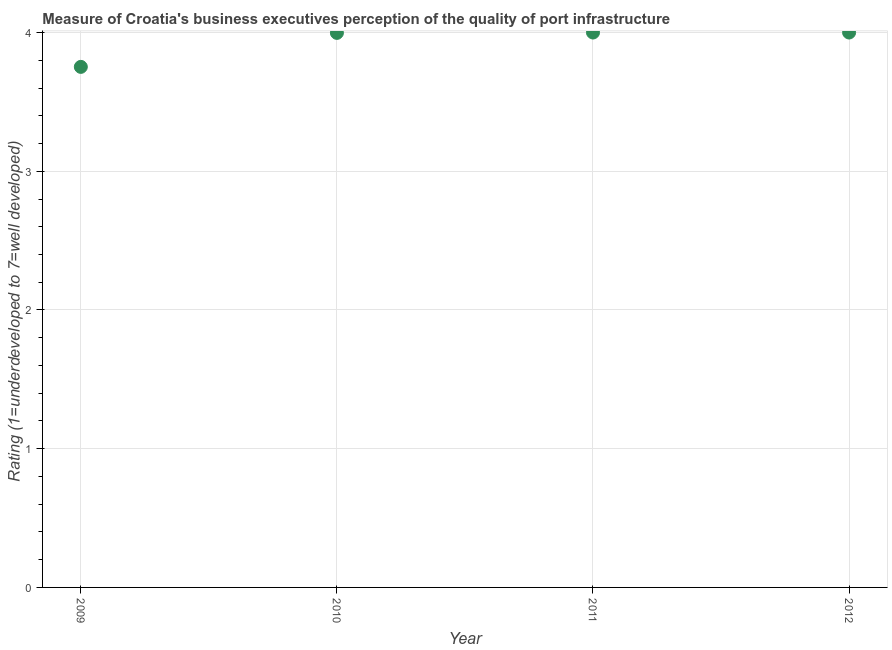What is the rating measuring quality of port infrastructure in 2011?
Provide a short and direct response. 4. Across all years, what is the maximum rating measuring quality of port infrastructure?
Provide a succinct answer. 4. Across all years, what is the minimum rating measuring quality of port infrastructure?
Make the answer very short. 3.75. What is the sum of the rating measuring quality of port infrastructure?
Offer a very short reply. 15.75. What is the average rating measuring quality of port infrastructure per year?
Keep it short and to the point. 3.94. What is the median rating measuring quality of port infrastructure?
Offer a terse response. 4. In how many years, is the rating measuring quality of port infrastructure greater than 3.6 ?
Make the answer very short. 4. Do a majority of the years between 2011 and 2010 (inclusive) have rating measuring quality of port infrastructure greater than 1.4 ?
Ensure brevity in your answer.  No. What is the ratio of the rating measuring quality of port infrastructure in 2010 to that in 2011?
Offer a terse response. 1. Is the difference between the rating measuring quality of port infrastructure in 2010 and 2012 greater than the difference between any two years?
Provide a short and direct response. No. What is the difference between the highest and the second highest rating measuring quality of port infrastructure?
Offer a terse response. 0. Is the sum of the rating measuring quality of port infrastructure in 2010 and 2012 greater than the maximum rating measuring quality of port infrastructure across all years?
Provide a short and direct response. Yes. What is the difference between the highest and the lowest rating measuring quality of port infrastructure?
Your answer should be compact. 0.25. Does the graph contain any zero values?
Offer a very short reply. No. What is the title of the graph?
Ensure brevity in your answer.  Measure of Croatia's business executives perception of the quality of port infrastructure. What is the label or title of the X-axis?
Provide a short and direct response. Year. What is the label or title of the Y-axis?
Offer a very short reply. Rating (1=underdeveloped to 7=well developed) . What is the Rating (1=underdeveloped to 7=well developed)  in 2009?
Your answer should be compact. 3.75. What is the Rating (1=underdeveloped to 7=well developed)  in 2010?
Offer a terse response. 4. What is the Rating (1=underdeveloped to 7=well developed)  in 2011?
Provide a succinct answer. 4. What is the Rating (1=underdeveloped to 7=well developed)  in 2012?
Your answer should be very brief. 4. What is the difference between the Rating (1=underdeveloped to 7=well developed)  in 2009 and 2010?
Give a very brief answer. -0.24. What is the difference between the Rating (1=underdeveloped to 7=well developed)  in 2009 and 2011?
Provide a succinct answer. -0.25. What is the difference between the Rating (1=underdeveloped to 7=well developed)  in 2009 and 2012?
Your answer should be very brief. -0.25. What is the difference between the Rating (1=underdeveloped to 7=well developed)  in 2010 and 2011?
Your answer should be compact. -0. What is the difference between the Rating (1=underdeveloped to 7=well developed)  in 2010 and 2012?
Offer a very short reply. -0. What is the difference between the Rating (1=underdeveloped to 7=well developed)  in 2011 and 2012?
Give a very brief answer. 0. What is the ratio of the Rating (1=underdeveloped to 7=well developed)  in 2009 to that in 2010?
Make the answer very short. 0.94. What is the ratio of the Rating (1=underdeveloped to 7=well developed)  in 2009 to that in 2011?
Offer a very short reply. 0.94. What is the ratio of the Rating (1=underdeveloped to 7=well developed)  in 2009 to that in 2012?
Provide a succinct answer. 0.94. 